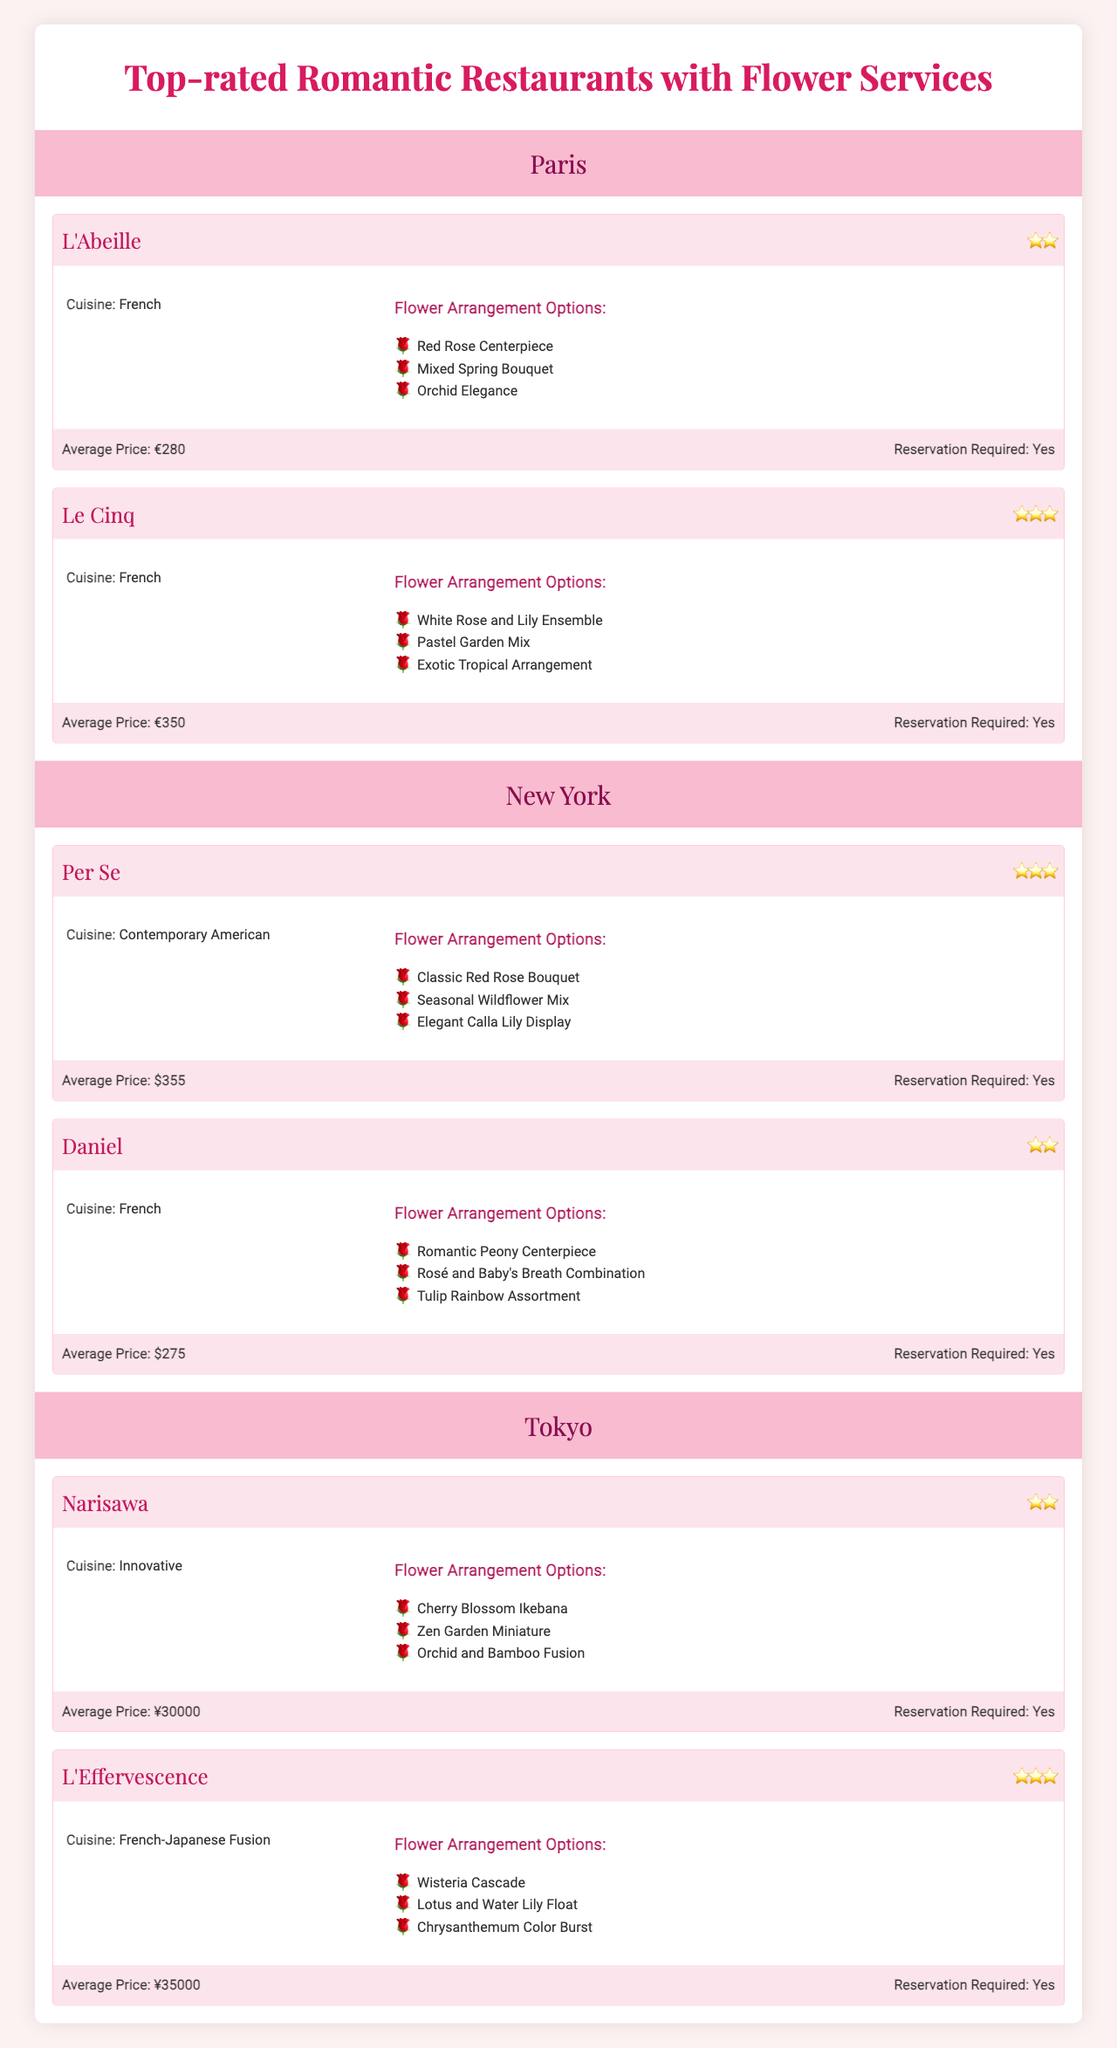What are the flower arrangement options available at Le Cinq in Paris? The table shows that the flower arrangement options for Le Cinq include "White Rose and Lily Ensemble," "Pastel Garden Mix," and "Exotic Tropical Arrangement."
Answer: "White Rose and Lily Ensemble," "Pastel Garden Mix," "Exotic Tropical Arrangement." How many Michelin stars does Daniel in New York have? According to the table, Daniel has 2 Michelin stars.
Answer: 2 What is the average price of dinner at L'Abeille? The average price listed for dinner at L'Abeille is €280.
Answer: €280 Is a reservation required for Narisawa? The table indicates that a reservation is required for Narisawa, as it states "Reservation Required: Yes."
Answer: Yes Which restaurant has the highest average price and what is it? Exploring the average prices listed, Le Cinq has the highest average price at €350.
Answer: €350 Which city features the restaurant with the most Michelin stars? From the table, Le Cinq in Paris has 3 Michelin stars, which is more than any restaurant in the other cities.
Answer: Paris If we combine the average prices of restaurants in New York, what is the total? The average prices are $355 for Per Se and $275 for Daniel. Adding them gives $355 + $275 = $630, so the total average price is $630.
Answer: $630 Are there more flower options available in Tokyo or New York? In the table, Narisawa and L'Effervescence in Tokyo offer 3 flower arrangement options each, while Per Se and Daniel in New York also provide 3 options each. So they are equal.
Answer: Equal What is the difference in average price between L'Effervescence and Le Cinq? L'Effervescence's average price is ¥35,000 and Le Cinq's is €350 (converting €350 to yen, based on common rates, it's approximately ¥46,000). Thus, the difference is ¥46,000 - ¥35,000 = ¥11,000.
Answer: ¥11,000 Which restaurant offers a "Cherry Blossom Ikebana" arrangement? The table specifies that "Cherry Blossom Ikebana" is an arrangement option available at Narisawa in Tokyo.
Answer: Narisawa 